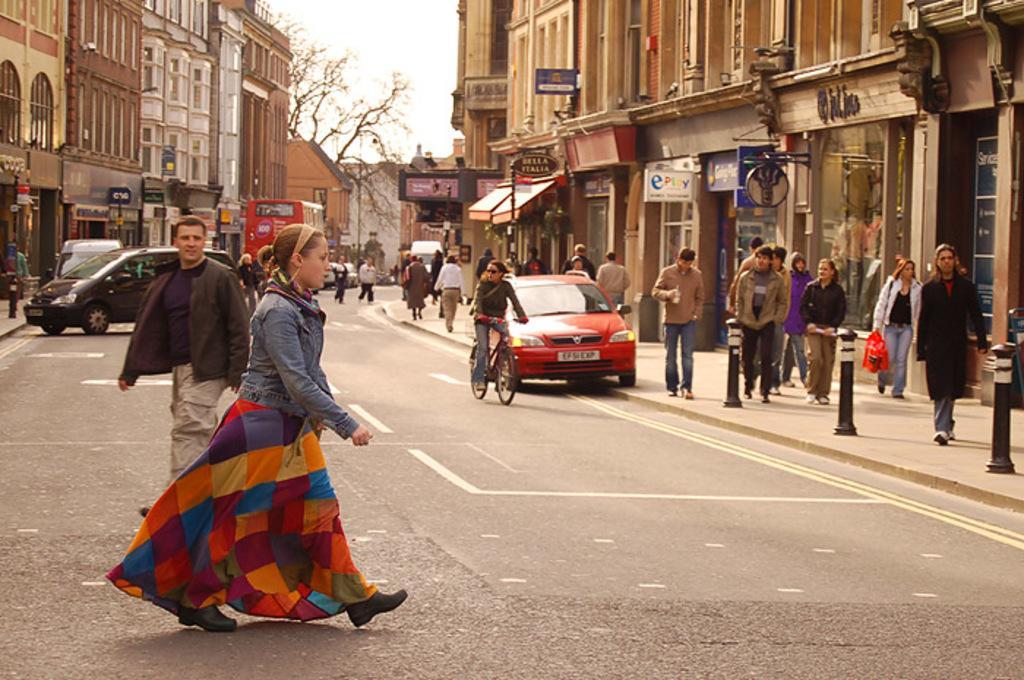Can you describe this image briefly? A woman is crossing the road. There are some people walking on the footpath. There are few cars and a bus in the background. 